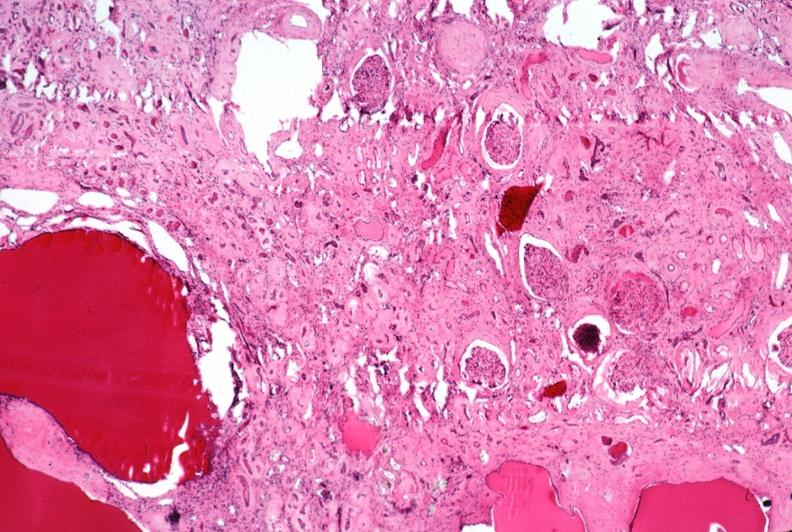what does this image show?
Answer the question using a single word or phrase. Kidney 